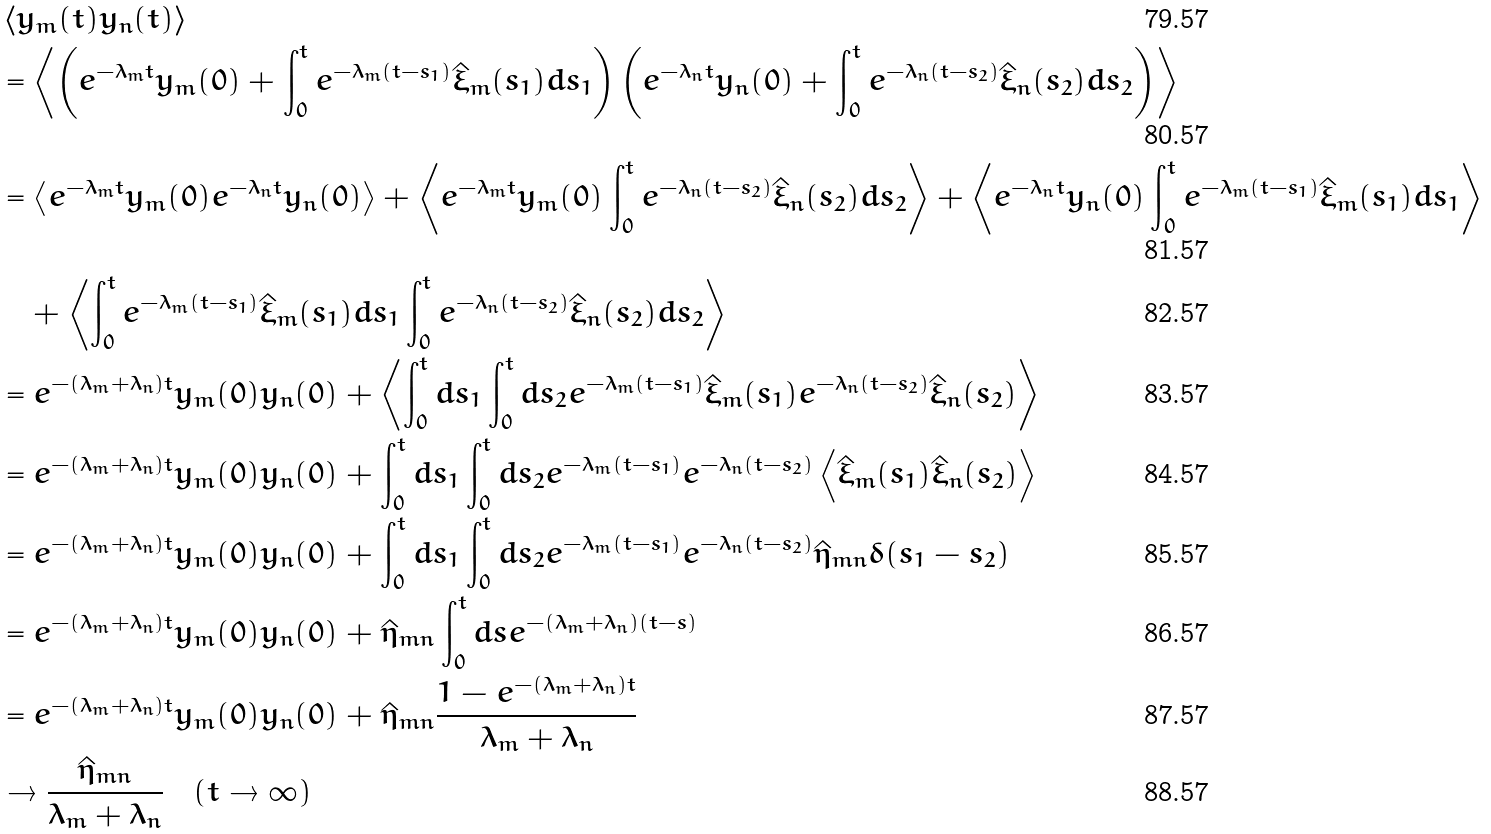<formula> <loc_0><loc_0><loc_500><loc_500>& \left \langle y _ { m } ( t ) y _ { n } ( t ) \right \rangle \\ & = \left \langle \left ( e ^ { - \lambda _ { m } t } y _ { m } ( 0 ) + \int _ { 0 } ^ { t } e ^ { - \lambda _ { m } ( t - s _ { 1 } ) } \hat { \xi } _ { m } ( s _ { 1 } ) d s _ { 1 } \right ) \left ( e ^ { - \lambda _ { n } t } y _ { n } ( 0 ) + \int _ { 0 } ^ { t } e ^ { - \lambda _ { n } ( t - s _ { 2 } ) } \hat { \xi } _ { n } ( s _ { 2 } ) d s _ { 2 } \right ) \right \rangle \\ & = \left \langle e ^ { - \lambda _ { m } t } y _ { m } ( 0 ) e ^ { - \lambda _ { n } t } y _ { n } ( 0 ) \right \rangle + \left \langle e ^ { - \lambda _ { m } t } y _ { m } ( 0 ) \int _ { 0 } ^ { t } e ^ { - \lambda _ { n } ( t - s _ { 2 } ) } \hat { \xi } _ { n } ( s _ { 2 } ) d s _ { 2 } \right \rangle + \left \langle e ^ { - \lambda _ { n } t } y _ { n } ( 0 ) \int _ { 0 } ^ { t } e ^ { - \lambda _ { m } ( t - s _ { 1 } ) } \hat { \xi } _ { m } ( s _ { 1 } ) d s _ { 1 } \right \rangle \\ & \quad + \left \langle \int _ { 0 } ^ { t } e ^ { - \lambda _ { m } ( t - s _ { 1 } ) } \hat { \xi } _ { m } ( s _ { 1 } ) d s _ { 1 } \int _ { 0 } ^ { t } e ^ { - \lambda _ { n } ( t - s _ { 2 } ) } \hat { \xi } _ { n } ( s _ { 2 } ) d s _ { 2 } \right \rangle \\ & = e ^ { - ( \lambda _ { m } + \lambda _ { n } ) t } y _ { m } ( 0 ) y _ { n } ( 0 ) + \left \langle \int _ { 0 } ^ { t } d s _ { 1 } \int _ { 0 } ^ { t } d s _ { 2 } e ^ { - \lambda _ { m } ( t - s _ { 1 } ) } \hat { \xi } _ { m } ( s _ { 1 } ) e ^ { - \lambda _ { n } ( t - s _ { 2 } ) } \hat { \xi } _ { n } ( s _ { 2 } ) \right \rangle \\ & = e ^ { - ( \lambda _ { m } + \lambda _ { n } ) t } y _ { m } ( 0 ) y _ { n } ( 0 ) + \int _ { 0 } ^ { t } d s _ { 1 } \int _ { 0 } ^ { t } d s _ { 2 } e ^ { - \lambda _ { m } ( t - s _ { 1 } ) } e ^ { - \lambda _ { n } ( t - s _ { 2 } ) } \left \langle \hat { \xi } _ { m } ( s _ { 1 } ) \hat { \xi } _ { n } ( s _ { 2 } ) \right \rangle \\ & = e ^ { - ( \lambda _ { m } + \lambda _ { n } ) t } y _ { m } ( 0 ) y _ { n } ( 0 ) + \int _ { 0 } ^ { t } d s _ { 1 } \int _ { 0 } ^ { t } d s _ { 2 } e ^ { - \lambda _ { m } ( t - s _ { 1 } ) } e ^ { - \lambda _ { n } ( t - s _ { 2 } ) } \hat { \eta } _ { m n } \delta ( s _ { 1 } - s _ { 2 } ) \\ & = e ^ { - ( \lambda _ { m } + \lambda _ { n } ) t } y _ { m } ( 0 ) y _ { n } ( 0 ) + \hat { \eta } _ { m n } \int _ { 0 } ^ { t } d s e ^ { - ( \lambda _ { m } + \lambda _ { n } ) ( t - s ) } \\ & = e ^ { - ( \lambda _ { m } + \lambda _ { n } ) t } y _ { m } ( 0 ) y _ { n } ( 0 ) + \hat { \eta } _ { m n } \frac { 1 - e ^ { - ( \lambda _ { m } + \lambda _ { n } ) t } } { \lambda _ { m } + \lambda _ { n } } \\ & \to \frac { \hat { \eta } _ { m n } } { \lambda _ { m } + \lambda _ { n } } \quad ( t \to \infty )</formula> 